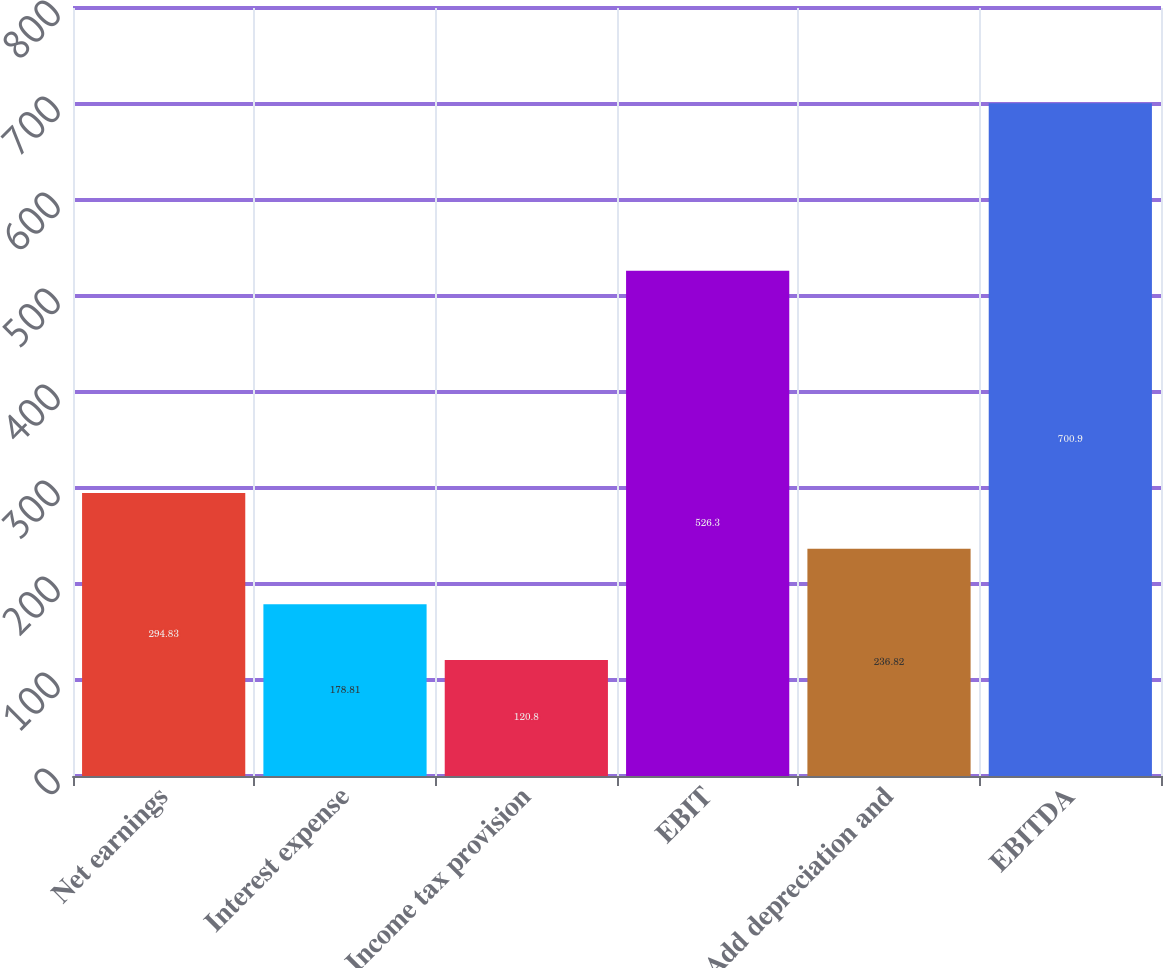<chart> <loc_0><loc_0><loc_500><loc_500><bar_chart><fcel>Net earnings<fcel>Interest expense<fcel>Income tax provision<fcel>EBIT<fcel>Add depreciation and<fcel>EBITDA<nl><fcel>294.83<fcel>178.81<fcel>120.8<fcel>526.3<fcel>236.82<fcel>700.9<nl></chart> 